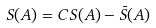<formula> <loc_0><loc_0><loc_500><loc_500>S ( A ) = C S ( A ) - \bar { S } ( A )</formula> 